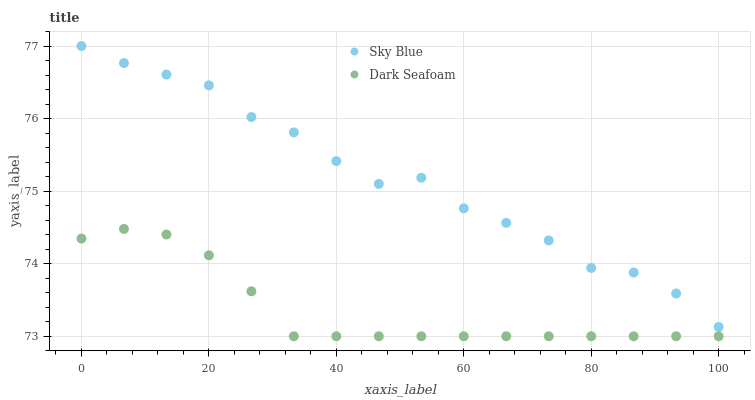Does Dark Seafoam have the minimum area under the curve?
Answer yes or no. Yes. Does Sky Blue have the maximum area under the curve?
Answer yes or no. Yes. Does Dark Seafoam have the maximum area under the curve?
Answer yes or no. No. Is Dark Seafoam the smoothest?
Answer yes or no. Yes. Is Sky Blue the roughest?
Answer yes or no. Yes. Is Dark Seafoam the roughest?
Answer yes or no. No. Does Dark Seafoam have the lowest value?
Answer yes or no. Yes. Does Sky Blue have the highest value?
Answer yes or no. Yes. Does Dark Seafoam have the highest value?
Answer yes or no. No. Is Dark Seafoam less than Sky Blue?
Answer yes or no. Yes. Is Sky Blue greater than Dark Seafoam?
Answer yes or no. Yes. Does Dark Seafoam intersect Sky Blue?
Answer yes or no. No. 